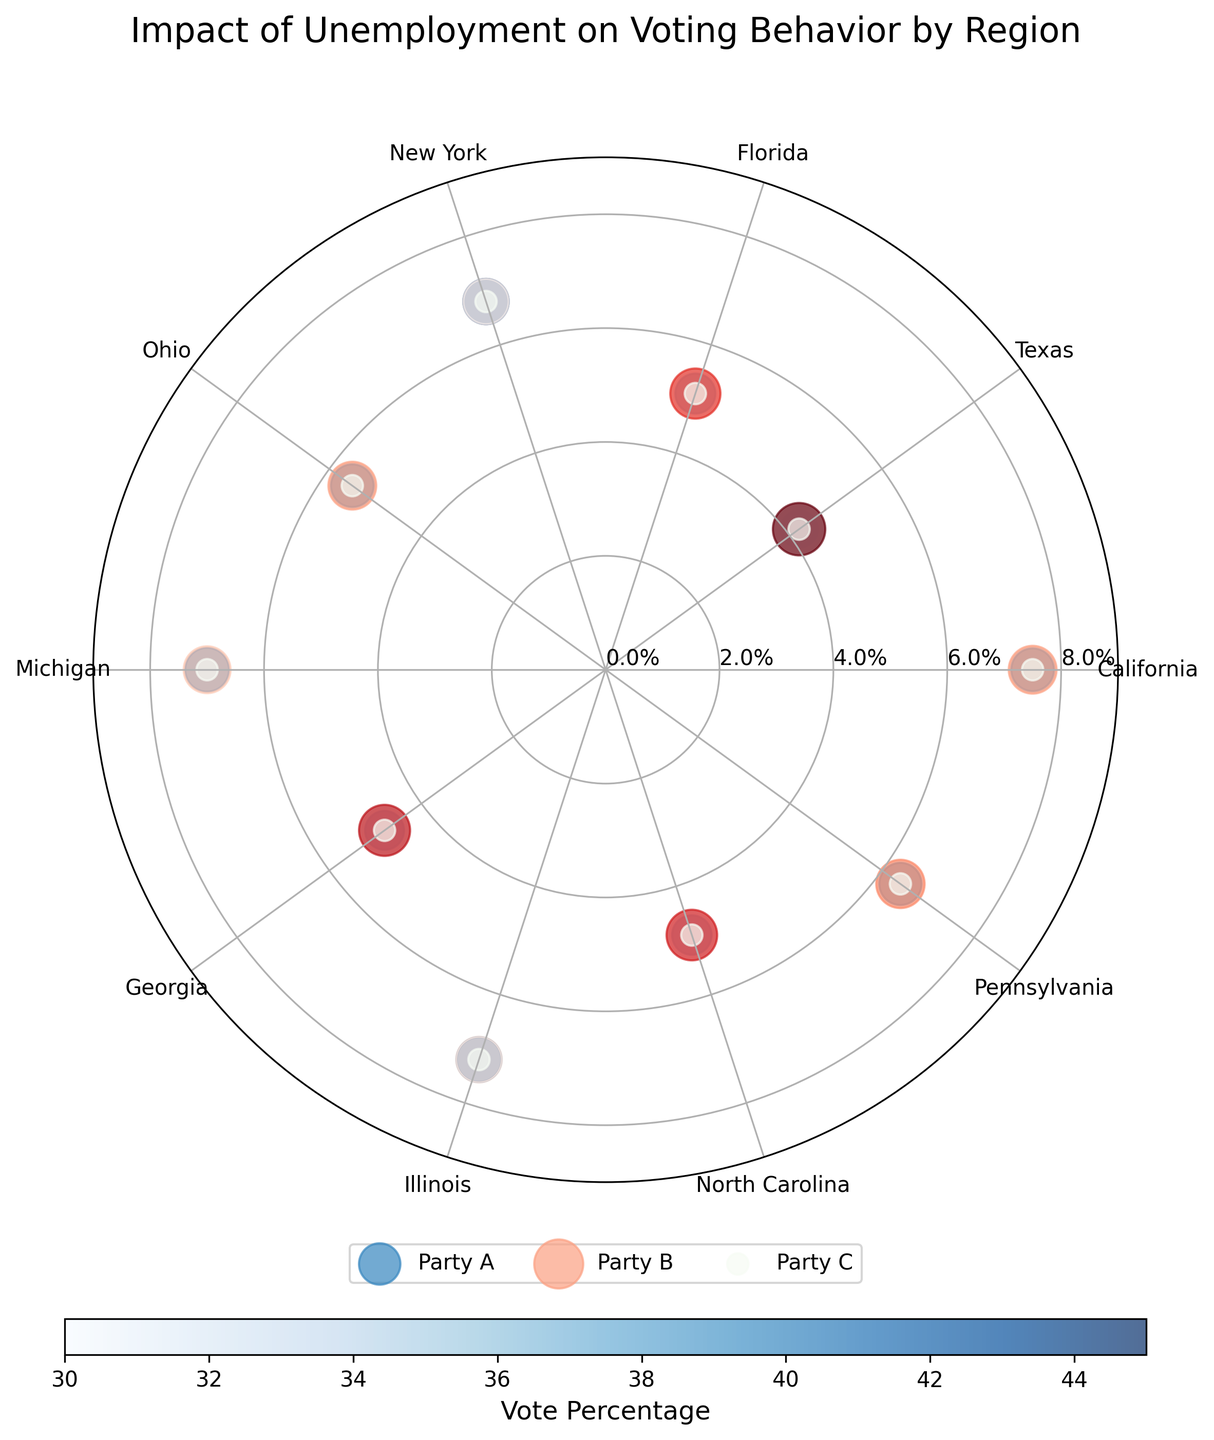How many regions have a data point represented in the chart? By counting the distinct regions labeled around the polar chart, we can see that there are 10 different regions represented.
Answer: 10 What is the title of the chart? The title is usually displayed at the top of the chart. Here, the title reads: "Impact of Unemployment on Voting Behavior by Region".
Answer: Impact of Unemployment on Voting Behavior by Region What is the highest unemployment rate displayed on the chart? The radial axis of the chart displays the unemployment rates. By looking at the outermost data points (furthest from the center), we can see that the highest unemployment rate is approximately 7.5%.
Answer: 7.5% Which party has a greater number of data points in regions with higher unemployment rates? Comparing the data points, Party A has more blue-colored points (related to higher unemployment values) further from the center, indicating that Party A has more data points in regions with higher unemployment.
Answer: Party A What is the average unemployment rate for New York, Ohio, and Pennsylvania? We locate New York, Ohio, and Pennsylvania on the chart and find their unemployment rates (6.8%, 5.5%, and 6.4% respectively). The average is calculated as (6.8 + 5.5 + 6.4) / 3.
Answer: 6.23% Which region has the highest percentage of votes for Party B? By comparing the sizes of data points with the color red (Party B's color), we find that Texas has the largest red data point, indicating the highest percentage of votes for Party B.
Answer: Texas Which region has the highest overall votes for Party C? Each green-colored data point represents Party C. Since all Party C data points are of the same size, indicating they all have the same percentage, we refer to the shared value.
Answer: All regions have the same What region has the lowest unemployment rate and who received the highest percentage of votes there? Locate the smallest radial point closest to the center (unemployment rate) and check the colors. Texas, with an unemployment rate of 4.2%, has Party B (red) receiving the highest percentage of votes.
Answer: Texas, Party B Is there a region where no party has an outright majority? An outright majority is more than 50%. By looking at all regions and their corresponding data points for Parties A, B, and C, New York is the region where both Party A and Party B have equal percentages (45%).
Answer: New York In which region does Party A have the closest percentage to Party B? By comparing the blue (Party A) and red (Party B) data points, New York shows an equal percentage of 45%, making it the closest.
Answer: New York 